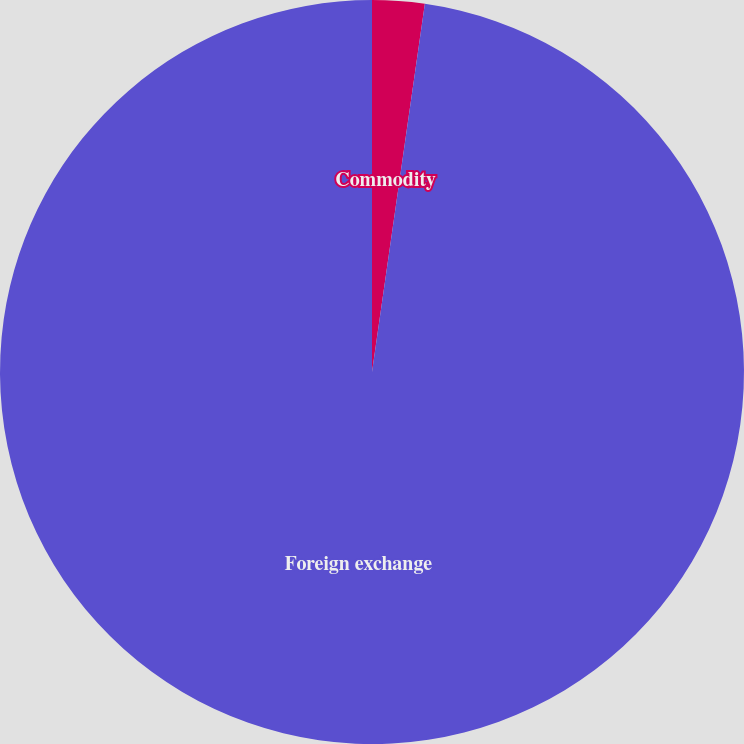<chart> <loc_0><loc_0><loc_500><loc_500><pie_chart><fcel>Commodity<fcel>Foreign exchange<nl><fcel>2.27%<fcel>97.73%<nl></chart> 